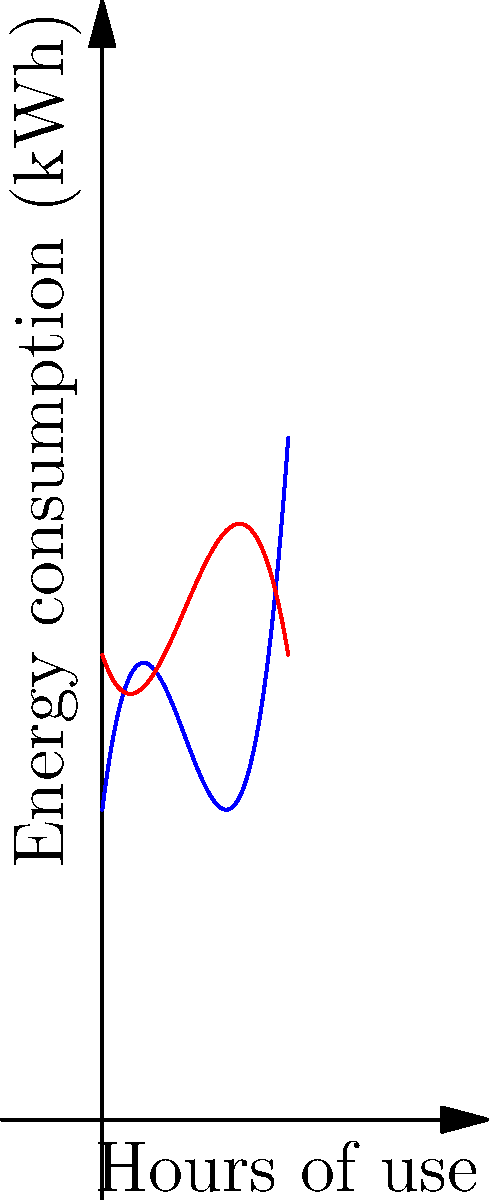Based on the polynomial graphs representing energy consumption of a kettle and a refrigerator over time, at approximately how many hours of use do these two appliances consume the same amount of energy? To find where the two appliances consume the same amount of energy, we need to determine where the two curves intersect. Let's approach this step-by-step:

1. The blue curve represents the kettle's energy consumption, while the red curve represents the refrigerator's energy consumption.

2. We can see that the curves intersect at two points: one near the origin and another between 4 and 5 hours.

3. The question asks for the approximate time, so we don't need to solve the equation algebraically.

4. By examining the graph closely, we can estimate that the second intersection point occurs at approximately 4.5 hours.

5. This means that after about 4.5 hours of continuous use, both appliances will have consumed the same amount of energy.

6. It's worth noting that in real-life scenarios, a kettle is typically used for short periods, while a refrigerator runs continuously. This graph is for illustrative purposes to compare energy consumption patterns.
Answer: Approximately 4.5 hours 